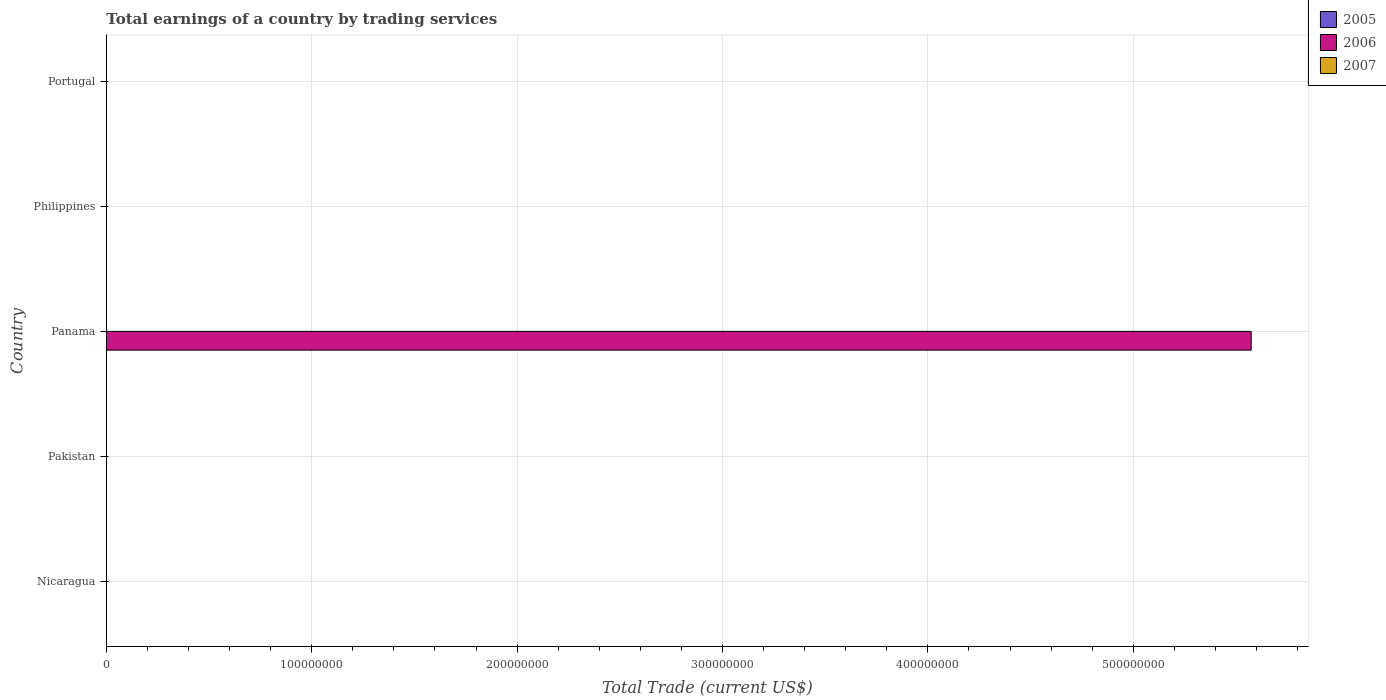What is the label of the 1st group of bars from the top?
Make the answer very short. Portugal. What is the total earnings in 2007 in Panama?
Make the answer very short. 0. Across all countries, what is the maximum total earnings in 2006?
Your response must be concise. 5.57e+08. Across all countries, what is the minimum total earnings in 2005?
Your answer should be very brief. 0. In which country was the total earnings in 2006 maximum?
Your answer should be very brief. Panama. What is the difference between the total earnings in 2007 in Philippines and the total earnings in 2006 in Pakistan?
Offer a terse response. 0. What is the average total earnings in 2006 per country?
Your response must be concise. 1.11e+08. What is the difference between the highest and the lowest total earnings in 2006?
Your answer should be compact. 5.57e+08. In how many countries, is the total earnings in 2005 greater than the average total earnings in 2005 taken over all countries?
Give a very brief answer. 0. Are all the bars in the graph horizontal?
Offer a very short reply. Yes. How many countries are there in the graph?
Provide a short and direct response. 5. What is the difference between two consecutive major ticks on the X-axis?
Offer a terse response. 1.00e+08. Are the values on the major ticks of X-axis written in scientific E-notation?
Your answer should be very brief. No. Does the graph contain any zero values?
Offer a very short reply. Yes. Does the graph contain grids?
Provide a succinct answer. Yes. How many legend labels are there?
Give a very brief answer. 3. What is the title of the graph?
Provide a short and direct response. Total earnings of a country by trading services. Does "2000" appear as one of the legend labels in the graph?
Keep it short and to the point. No. What is the label or title of the X-axis?
Offer a terse response. Total Trade (current US$). What is the Total Trade (current US$) of 2005 in Pakistan?
Your answer should be very brief. 0. What is the Total Trade (current US$) in 2006 in Pakistan?
Your answer should be compact. 0. What is the Total Trade (current US$) in 2006 in Panama?
Keep it short and to the point. 5.57e+08. What is the Total Trade (current US$) in 2006 in Philippines?
Offer a very short reply. 0. What is the Total Trade (current US$) of 2006 in Portugal?
Give a very brief answer. 0. What is the Total Trade (current US$) of 2007 in Portugal?
Provide a short and direct response. 0. Across all countries, what is the maximum Total Trade (current US$) in 2006?
Offer a terse response. 5.57e+08. What is the total Total Trade (current US$) of 2006 in the graph?
Make the answer very short. 5.57e+08. What is the total Total Trade (current US$) in 2007 in the graph?
Give a very brief answer. 0. What is the average Total Trade (current US$) of 2005 per country?
Ensure brevity in your answer.  0. What is the average Total Trade (current US$) in 2006 per country?
Your response must be concise. 1.11e+08. What is the average Total Trade (current US$) in 2007 per country?
Offer a terse response. 0. What is the difference between the highest and the lowest Total Trade (current US$) of 2006?
Provide a short and direct response. 5.57e+08. 